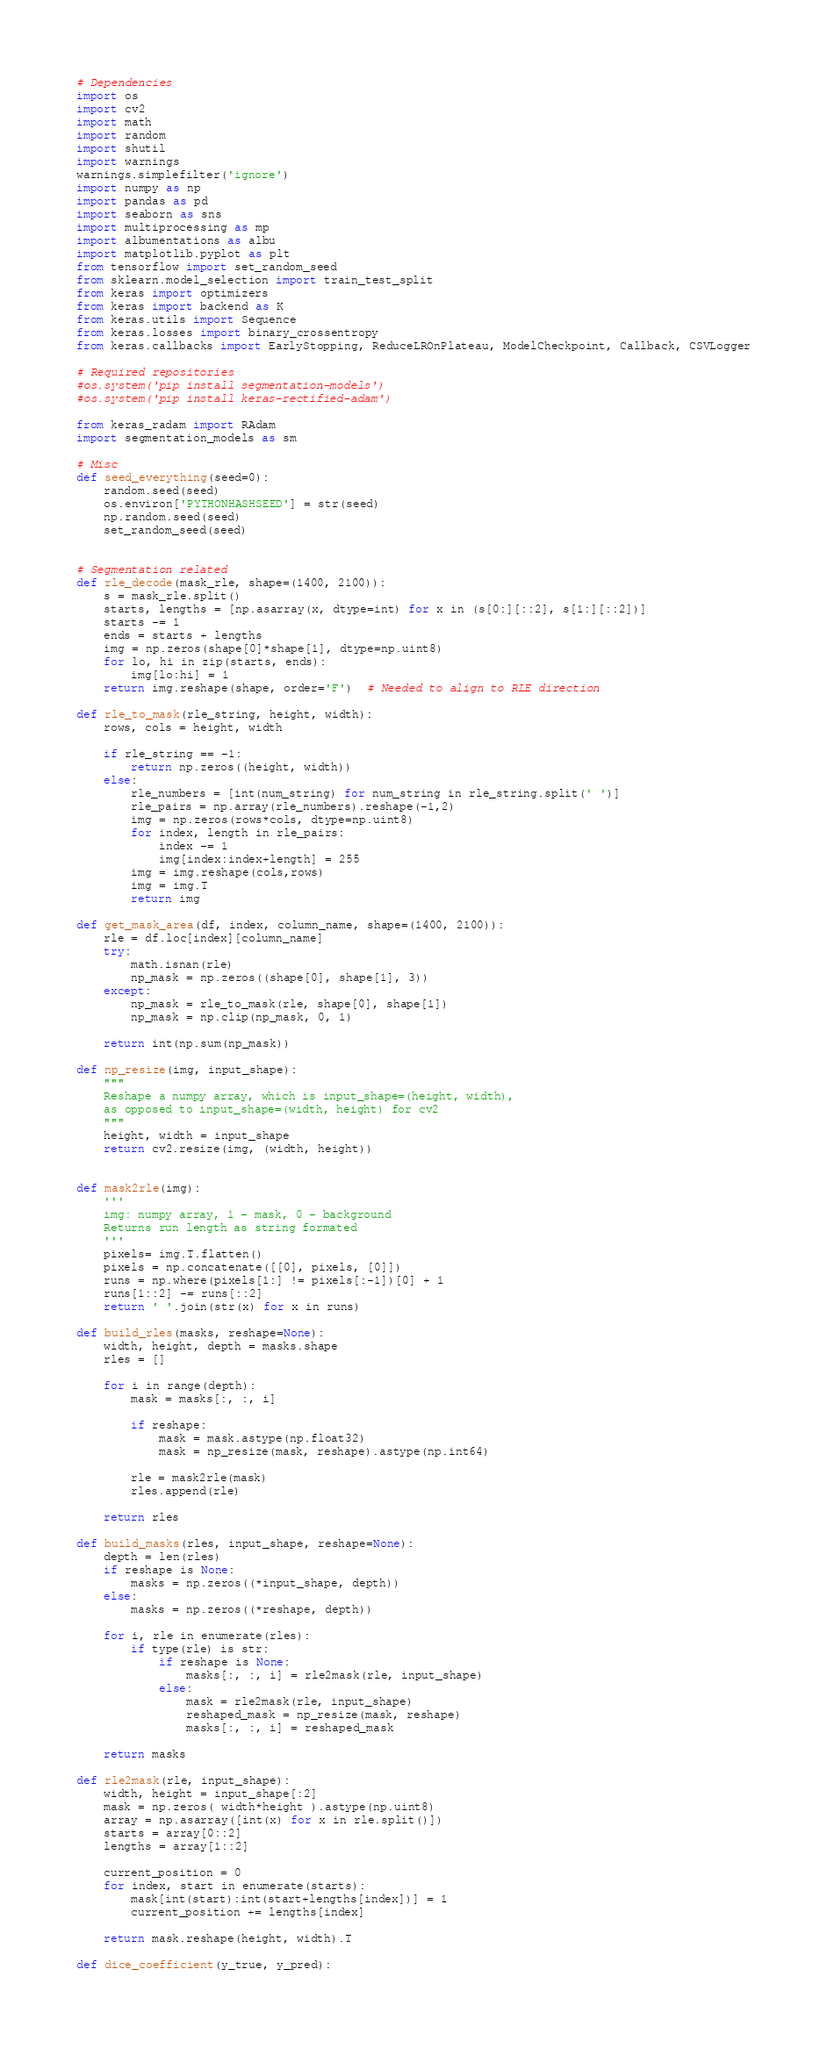Convert code to text. <code><loc_0><loc_0><loc_500><loc_500><_Python_># Dependencies
import os
import cv2
import math
import random
import shutil
import warnings
warnings.simplefilter('ignore')
import numpy as np
import pandas as pd
import seaborn as sns
import multiprocessing as mp
import albumentations as albu
import matplotlib.pyplot as plt
from tensorflow import set_random_seed
from sklearn.model_selection import train_test_split
from keras import optimizers
from keras import backend as K
from keras.utils import Sequence
from keras.losses import binary_crossentropy
from keras.callbacks import EarlyStopping, ReduceLROnPlateau, ModelCheckpoint, Callback, CSVLogger

# Required repositories
#os.system('pip install segmentation-models')
#os.system('pip install keras-rectified-adam')

from keras_radam import RAdam
import segmentation_models as sm

# Misc
def seed_everything(seed=0):
    random.seed(seed)
    os.environ['PYTHONHASHSEED'] = str(seed)
    np.random.seed(seed)
    set_random_seed(seed)
    
    
# Segmentation related
def rle_decode(mask_rle, shape=(1400, 2100)):
    s = mask_rle.split()
    starts, lengths = [np.asarray(x, dtype=int) for x in (s[0:][::2], s[1:][::2])]
    starts -= 1
    ends = starts + lengths
    img = np.zeros(shape[0]*shape[1], dtype=np.uint8)
    for lo, hi in zip(starts, ends):
        img[lo:hi] = 1
    return img.reshape(shape, order='F')  # Needed to align to RLE direction

def rle_to_mask(rle_string, height, width):
    rows, cols = height, width
    
    if rle_string == -1:
        return np.zeros((height, width))
    else:
        rle_numbers = [int(num_string) for num_string in rle_string.split(' ')]
        rle_pairs = np.array(rle_numbers).reshape(-1,2)
        img = np.zeros(rows*cols, dtype=np.uint8)
        for index, length in rle_pairs:
            index -= 1
            img[index:index+length] = 255
        img = img.reshape(cols,rows)
        img = img.T
        return img
    
def get_mask_area(df, index, column_name, shape=(1400, 2100)):
    rle = df.loc[index][column_name]
    try:
        math.isnan(rle)
        np_mask = np.zeros((shape[0], shape[1], 3))
    except:
        np_mask = rle_to_mask(rle, shape[0], shape[1])
        np_mask = np.clip(np_mask, 0, 1)
        
    return int(np.sum(np_mask))

def np_resize(img, input_shape):
    """
    Reshape a numpy array, which is input_shape=(height, width), 
    as opposed to input_shape=(width, height) for cv2
    """
    height, width = input_shape
    return cv2.resize(img, (width, height))
    
    
def mask2rle(img):
    '''
    img: numpy array, 1 - mask, 0 - background
    Returns run length as string formated
    '''
    pixels= img.T.flatten()
    pixels = np.concatenate([[0], pixels, [0]])
    runs = np.where(pixels[1:] != pixels[:-1])[0] + 1
    runs[1::2] -= runs[::2]
    return ' '.join(str(x) for x in runs)

def build_rles(masks, reshape=None):
    width, height, depth = masks.shape
    rles = []
    
    for i in range(depth):
        mask = masks[:, :, i]
        
        if reshape:
            mask = mask.astype(np.float32)
            mask = np_resize(mask, reshape).astype(np.int64)
        
        rle = mask2rle(mask)
        rles.append(rle)
        
    return rles

def build_masks(rles, input_shape, reshape=None):
    depth = len(rles)
    if reshape is None:
        masks = np.zeros((*input_shape, depth))
    else:
        masks = np.zeros((*reshape, depth))
    
    for i, rle in enumerate(rles):
        if type(rle) is str:
            if reshape is None:
                masks[:, :, i] = rle2mask(rle, input_shape)
            else:
                mask = rle2mask(rle, input_shape)
                reshaped_mask = np_resize(mask, reshape)
                masks[:, :, i] = reshaped_mask
    
    return masks

def rle2mask(rle, input_shape):
    width, height = input_shape[:2]
    mask = np.zeros( width*height ).astype(np.uint8)
    array = np.asarray([int(x) for x in rle.split()])
    starts = array[0::2]
    lengths = array[1::2]

    current_position = 0
    for index, start in enumerate(starts):
        mask[int(start):int(start+lengths[index])] = 1
        current_position += lengths[index]
        
    return mask.reshape(height, width).T

def dice_coefficient(y_true, y_pred):</code> 